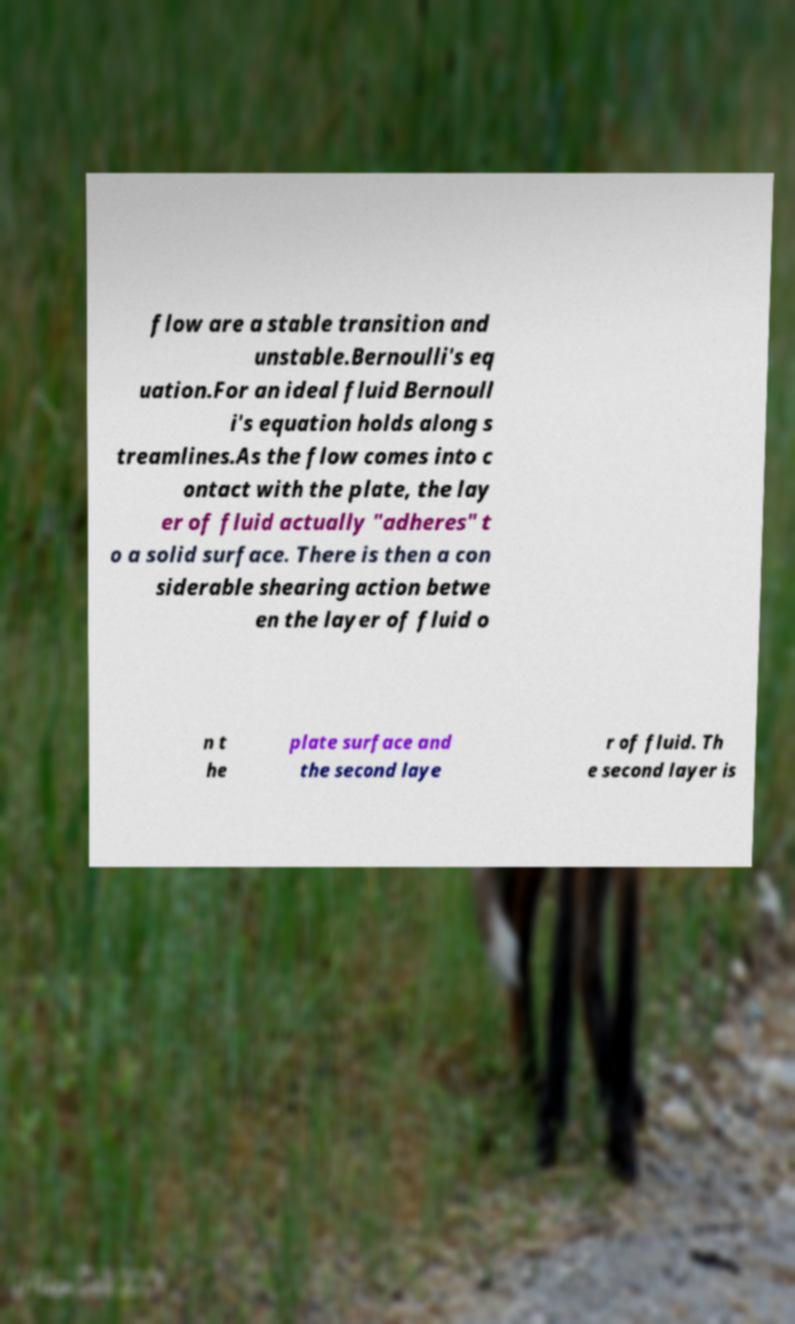Can you read and provide the text displayed in the image?This photo seems to have some interesting text. Can you extract and type it out for me? flow are a stable transition and unstable.Bernoulli's eq uation.For an ideal fluid Bernoull i's equation holds along s treamlines.As the flow comes into c ontact with the plate, the lay er of fluid actually "adheres" t o a solid surface. There is then a con siderable shearing action betwe en the layer of fluid o n t he plate surface and the second laye r of fluid. Th e second layer is 